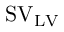Convert formula to latex. <formula><loc_0><loc_0><loc_500><loc_500>S V _ { L V }</formula> 